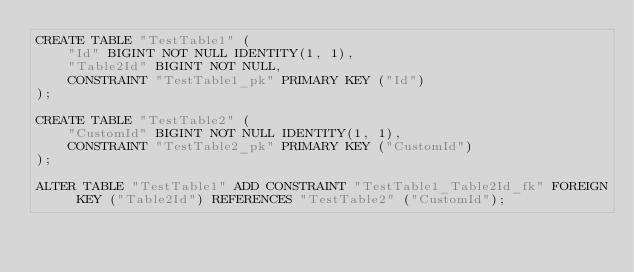Convert code to text. <code><loc_0><loc_0><loc_500><loc_500><_SQL_>CREATE TABLE "TestTable1" (
    "Id" BIGINT NOT NULL IDENTITY(1, 1),
    "Table2Id" BIGINT NOT NULL,
    CONSTRAINT "TestTable1_pk" PRIMARY KEY ("Id")
);

CREATE TABLE "TestTable2" (
    "CustomId" BIGINT NOT NULL IDENTITY(1, 1),
    CONSTRAINT "TestTable2_pk" PRIMARY KEY ("CustomId")
);

ALTER TABLE "TestTable1" ADD CONSTRAINT "TestTable1_Table2Id_fk" FOREIGN KEY ("Table2Id") REFERENCES "TestTable2" ("CustomId");</code> 